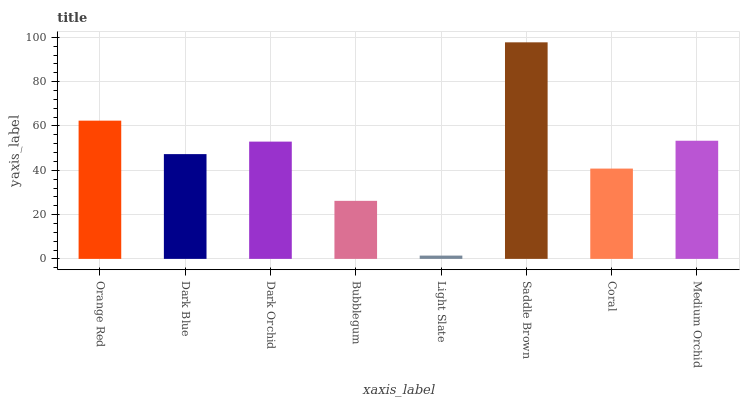Is Dark Blue the minimum?
Answer yes or no. No. Is Dark Blue the maximum?
Answer yes or no. No. Is Orange Red greater than Dark Blue?
Answer yes or no. Yes. Is Dark Blue less than Orange Red?
Answer yes or no. Yes. Is Dark Blue greater than Orange Red?
Answer yes or no. No. Is Orange Red less than Dark Blue?
Answer yes or no. No. Is Dark Orchid the high median?
Answer yes or no. Yes. Is Dark Blue the low median?
Answer yes or no. Yes. Is Medium Orchid the high median?
Answer yes or no. No. Is Medium Orchid the low median?
Answer yes or no. No. 